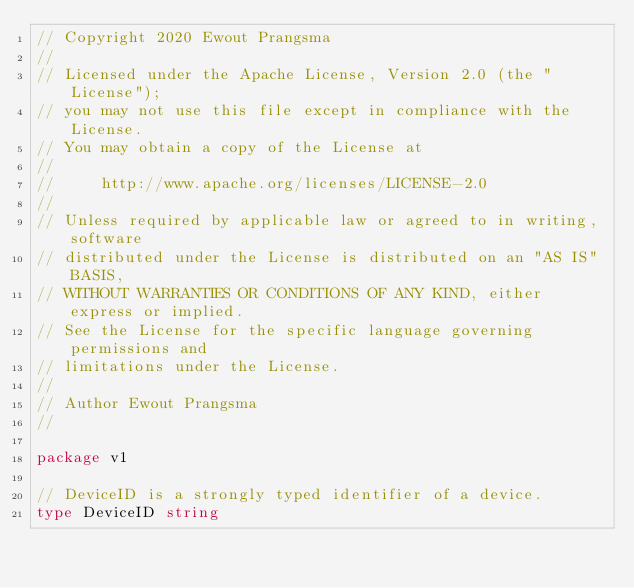<code> <loc_0><loc_0><loc_500><loc_500><_Go_>// Copyright 2020 Ewout Prangsma
//
// Licensed under the Apache License, Version 2.0 (the "License");
// you may not use this file except in compliance with the License.
// You may obtain a copy of the License at
//
//     http://www.apache.org/licenses/LICENSE-2.0
//
// Unless required by applicable law or agreed to in writing, software
// distributed under the License is distributed on an "AS IS" BASIS,
// WITHOUT WARRANTIES OR CONDITIONS OF ANY KIND, either express or implied.
// See the License for the specific language governing permissions and
// limitations under the License.
//
// Author Ewout Prangsma
//

package v1

// DeviceID is a strongly typed identifier of a device.
type DeviceID string
</code> 